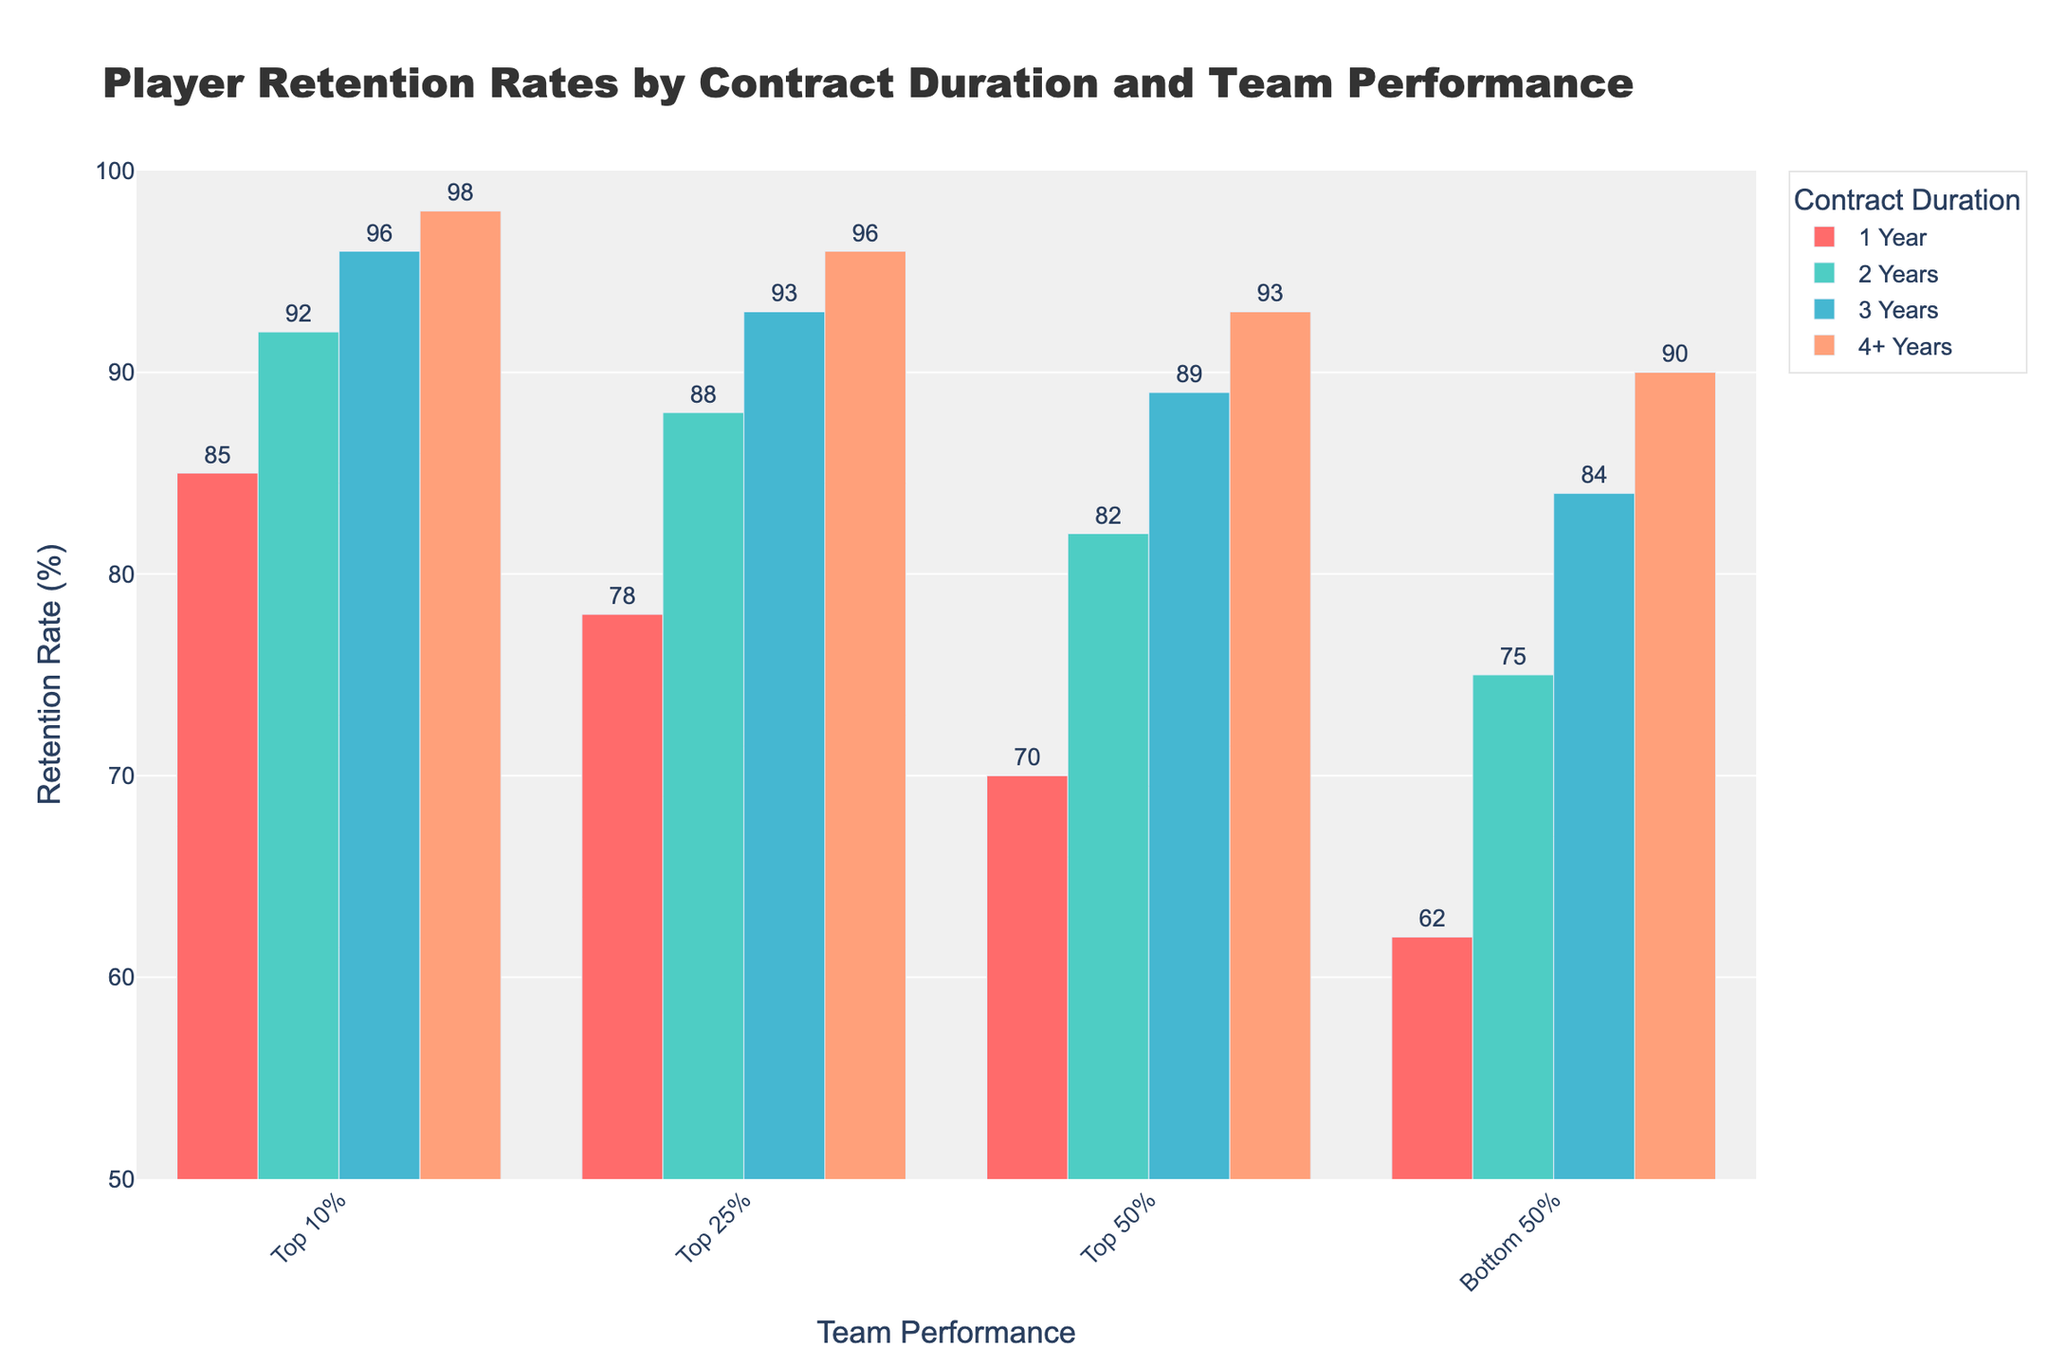What is the retention rate for players with a 3-year contract in the Top 10% team performance? The retention rate for players with a 3-year contract is represented by the height of the red bar for the Top 10% performance group. Referring to the figure, the retention rate is labeled directly on the bar.
Answer: 96% Which team performance group has the highest retention rate for players with a 1-year contract? Compare the bars representing the retention rates for 1-year contracts across all performance groups. The tallest bar corresponds to the Top 10% performance group.
Answer: Top 10% How does the retention rate for the Top 25% team performance compare between 2-year and 3-year contracts? Look at the heights of the bars for the Top 25% performance group under 2-year and 3-year contracts. The retention rates are 88% and 93%, respectively.
Answer: 3-year contract has a higher retention rate What is the average retention rate for players with a 4+ year contract? Add the retention rates for all team performance groups under 4+ year contracts and divide by the number of groups (98% + 96% + 93% + 90%) / 4.
Answer: 94.25% Does the Bottom 50% team performance group have a retention rate greater than 80% for any contract duration? Examine the retention rates for the Bottom 50% team performance for all contract durations. The highest rate is 84% for 3-year contracts.
Answer: Yes What is the difference in retention rates between the Top 10% and Bottom 50% team performance for a 2-year contract duration? Subtract the retention rate for the Bottom 50% (75%) from that of the Top 10% (92%) for the 2-year contract duration.
Answer: 17% Which contract duration has the closest retention rates across all team performance groups? Compare the ranges of retention rates for each contract duration. The 4+ year contract durations have the smallest range (98% - 90% = 8%).
Answer: 4+ years What trend do you notice in retention rates as the contract duration increases for the Top 50% team performance group? Follow the height of the bars for the Top 50% team performance group as the contract duration increases. The retention rates steadily increase from 70% to 93%.
Answer: Increasing trend What is the retention rate for the Top 25% team performance with a 1-year contract compared to a 4+ year contract? Look at the bars for the Top 25% performance group for 1-year and 4+ year contracts. The rates are 78% and 96%, respectively.
Answer: 4+ year contract has a higher retention rate How does the retention rate for the Bottom 50% team performance for a 1-year contract compare to the retention rate for the same performance but for a 3-year contract? Compare the retention rates for the Bottom 50% team performance group for 1-year (62%) and 3-year contracts (84%).
Answer: 3-year contract has a higher retention rate 